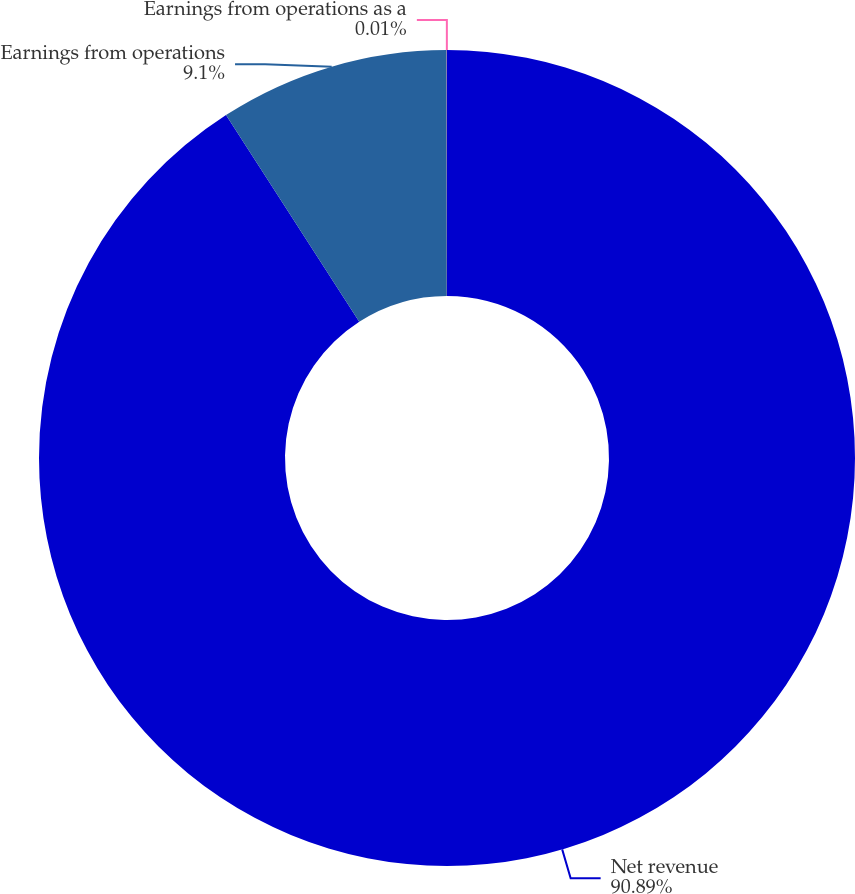Convert chart. <chart><loc_0><loc_0><loc_500><loc_500><pie_chart><fcel>Net revenue<fcel>Earnings from operations<fcel>Earnings from operations as a<nl><fcel>90.89%<fcel>9.1%<fcel>0.01%<nl></chart> 